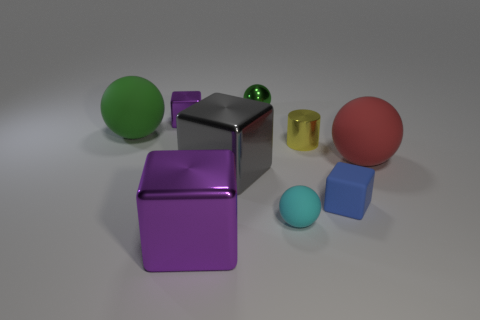There is a tiny ball that is left of the tiny cyan ball; what material is it?
Your response must be concise. Metal. Are there fewer large red matte objects than big brown rubber cylinders?
Make the answer very short. No. There is a cyan rubber object; is it the same shape as the big object that is right of the shiny cylinder?
Provide a short and direct response. Yes. There is a object that is on the right side of the green metallic ball and in front of the small matte block; what is its shape?
Give a very brief answer. Sphere. Is the number of tiny spheres behind the cyan matte thing the same as the number of small shiny blocks that are in front of the small matte cube?
Your answer should be compact. No. There is a small shiny object behind the small purple block; does it have the same shape as the red matte object?
Make the answer very short. Yes. How many purple objects are metallic balls or small shiny cubes?
Ensure brevity in your answer.  1. What is the material of the large red object that is the same shape as the tiny green object?
Your response must be concise. Rubber. There is a big rubber object right of the blue block; what is its shape?
Ensure brevity in your answer.  Sphere. Are there any small brown spheres made of the same material as the large purple thing?
Your response must be concise. No. 